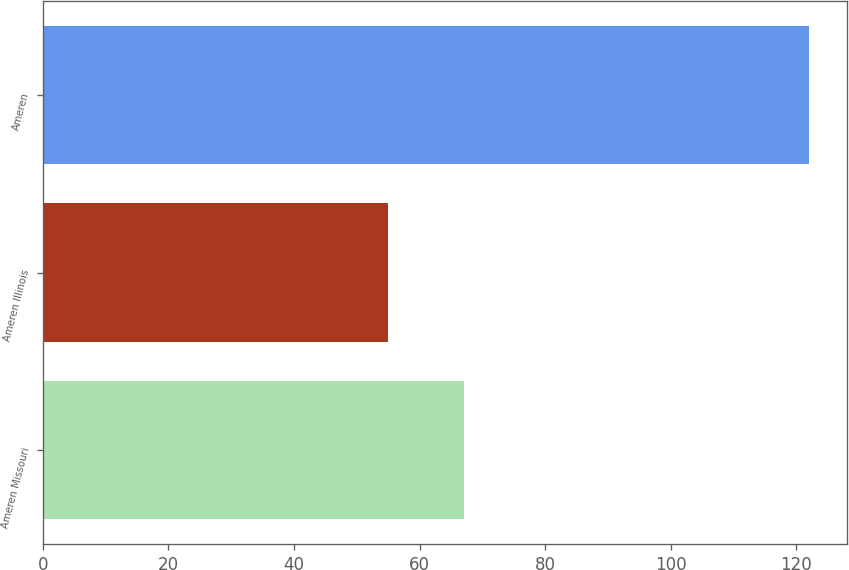Convert chart to OTSL. <chart><loc_0><loc_0><loc_500><loc_500><bar_chart><fcel>Ameren Missouri<fcel>Ameren Illinois<fcel>Ameren<nl><fcel>67<fcel>55<fcel>122<nl></chart> 